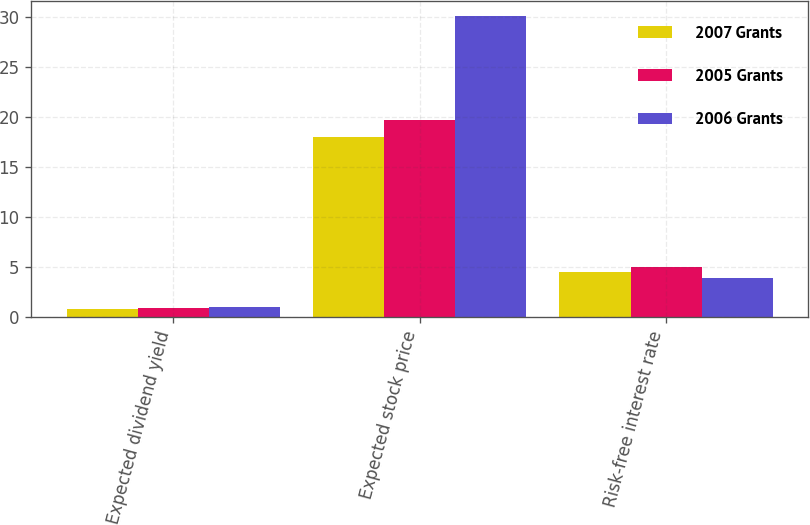Convert chart to OTSL. <chart><loc_0><loc_0><loc_500><loc_500><stacked_bar_chart><ecel><fcel>Expected dividend yield<fcel>Expected stock price<fcel>Risk-free interest rate<nl><fcel>2007 Grants<fcel>0.81<fcel>17.94<fcel>4.55<nl><fcel>2005 Grants<fcel>0.92<fcel>19.7<fcel>5.01<nl><fcel>2006 Grants<fcel>1.01<fcel>30.09<fcel>3.89<nl></chart> 